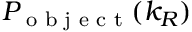<formula> <loc_0><loc_0><loc_500><loc_500>P _ { o b j e c t } ( k _ { R } )</formula> 